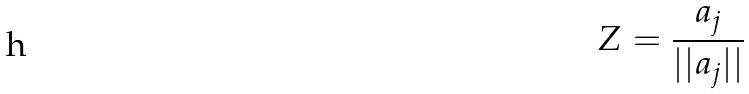Convert formula to latex. <formula><loc_0><loc_0><loc_500><loc_500>Z = \frac { a _ { j } } { | | a _ { j } | | }</formula> 